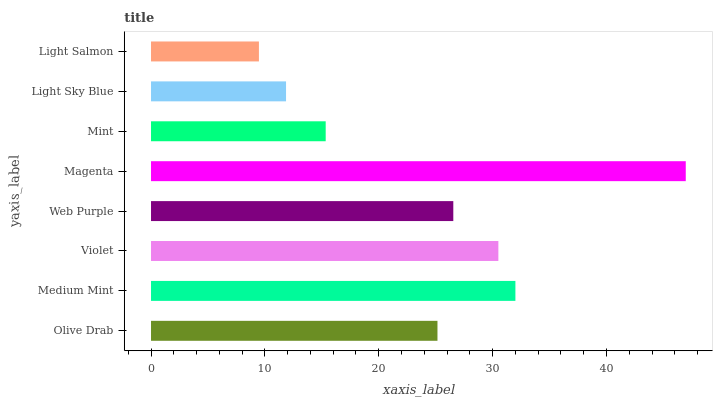Is Light Salmon the minimum?
Answer yes or no. Yes. Is Magenta the maximum?
Answer yes or no. Yes. Is Medium Mint the minimum?
Answer yes or no. No. Is Medium Mint the maximum?
Answer yes or no. No. Is Medium Mint greater than Olive Drab?
Answer yes or no. Yes. Is Olive Drab less than Medium Mint?
Answer yes or no. Yes. Is Olive Drab greater than Medium Mint?
Answer yes or no. No. Is Medium Mint less than Olive Drab?
Answer yes or no. No. Is Web Purple the high median?
Answer yes or no. Yes. Is Olive Drab the low median?
Answer yes or no. Yes. Is Light Sky Blue the high median?
Answer yes or no. No. Is Mint the low median?
Answer yes or no. No. 